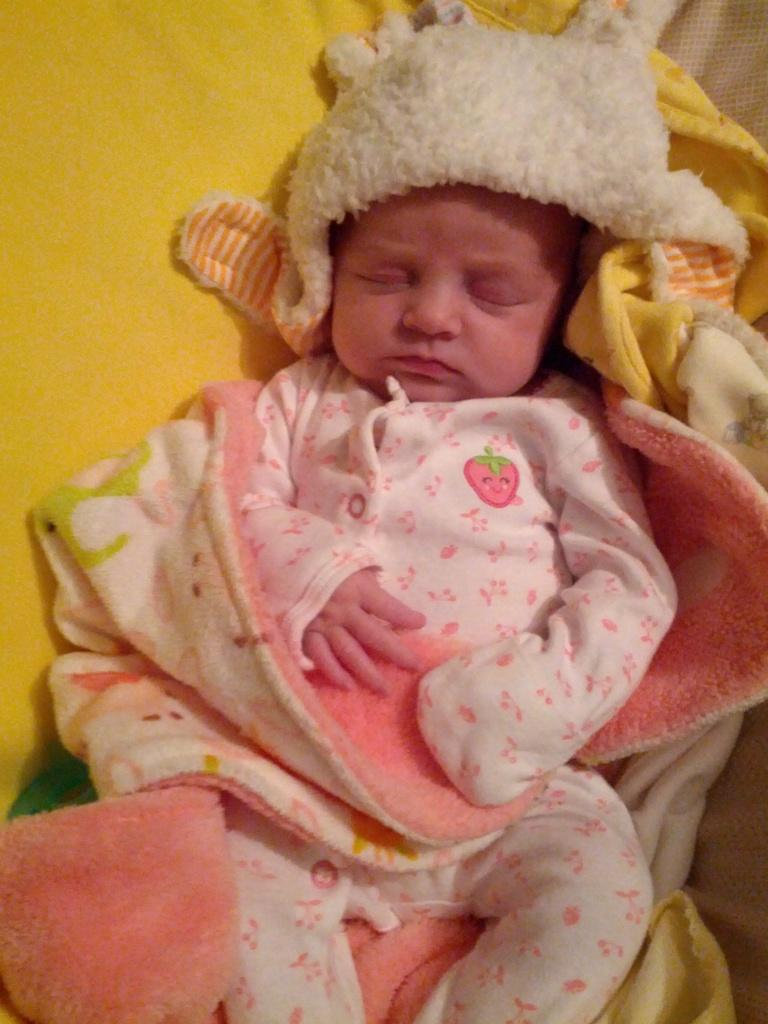What is the main subject of the image? There is a baby in the image. What is the baby doing in the image? The baby is sleeping. What color is the cloth visible in the background of the image? There is a yellow colored cloth in the background of the image. Can you see any toads interacting with the baby in the image? There are no toads present in the image. What type of war is depicted in the image? There is no war depicted in the image; it features a sleeping baby and a yellow cloth in the background. 